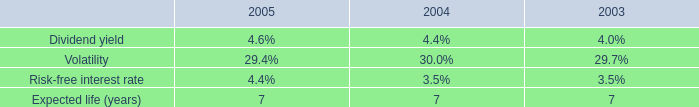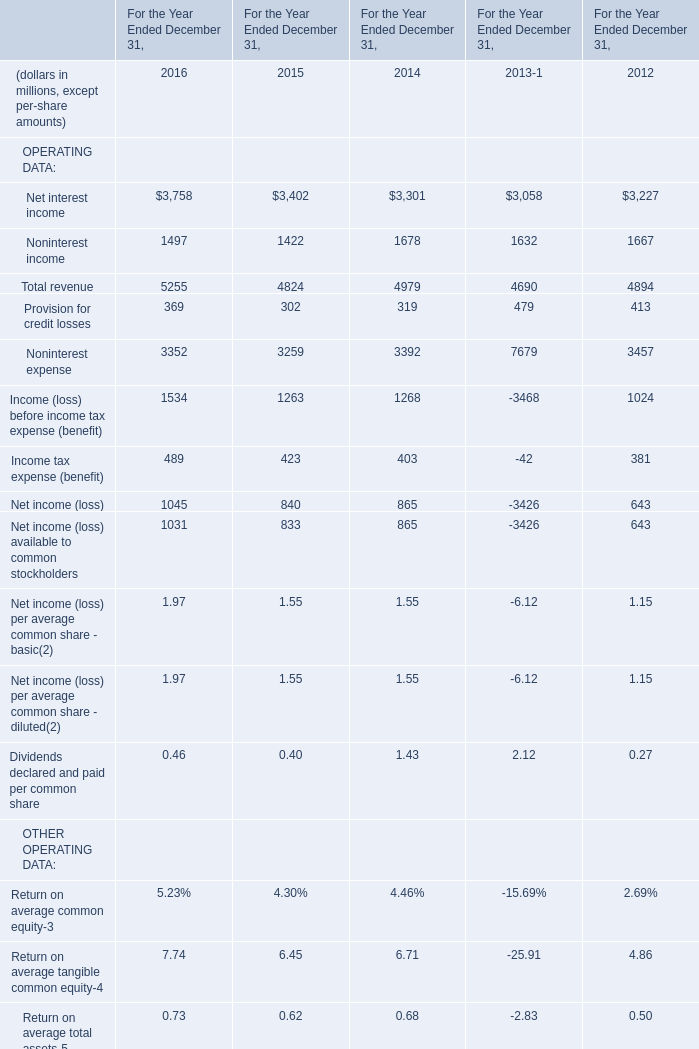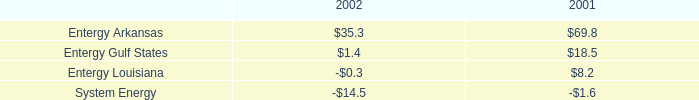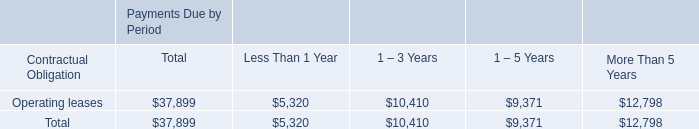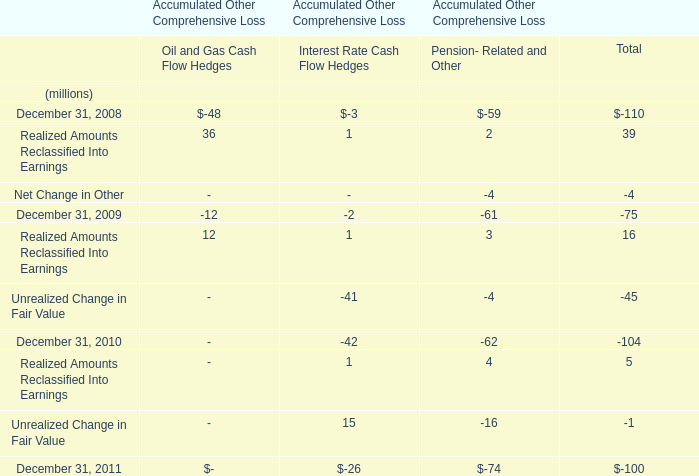What was the average value of Net interest income, Noninterest income,Provision for credit losses in 2016 ? (in million) 
Computations: (((3758 + 1497) + 369) / 3)
Answer: 1874.66667. 